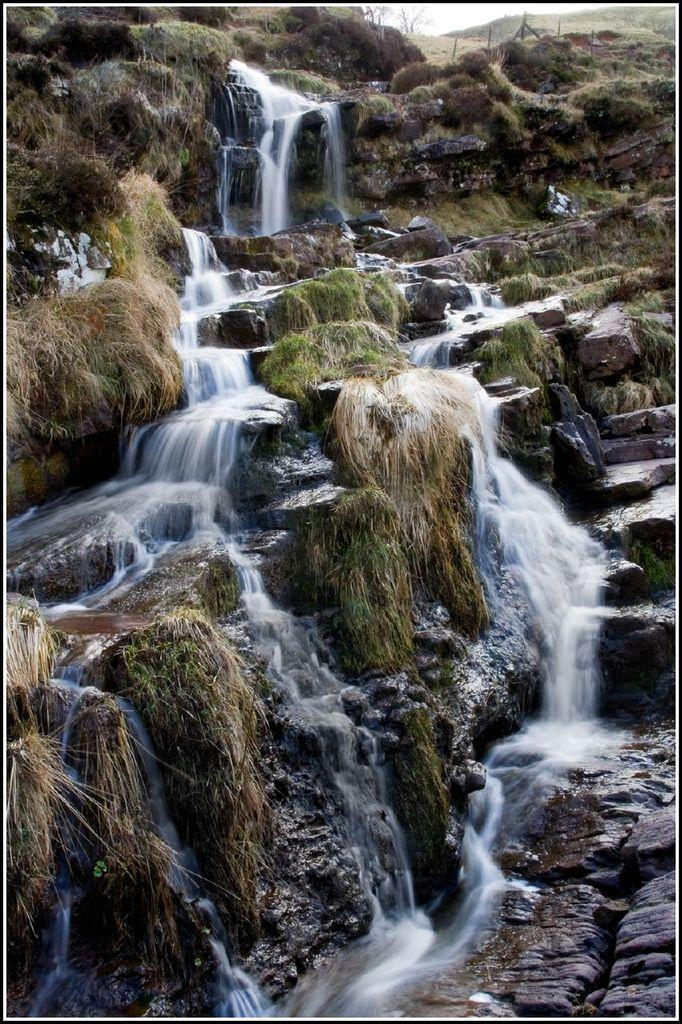What type of natural formations can be seen in the image? There are huge rocks in the image. What type of vegetation is visible in the image? There is grass and plants visible in the image. What is happening to the water in the image? Water is falling from the top of the rocks. What can be seen in the background of the image? There are poles and the sky visible in the background of the image. Can you tell me how many bananas are hanging from the rocks in the image? There are no bananas present in the image; it features rocks, grass, plants, water, poles, and the sky. What type of wool is being used to create the plants on the rocks? There is no wool present in the image; the plants are natural and not made of wool. 